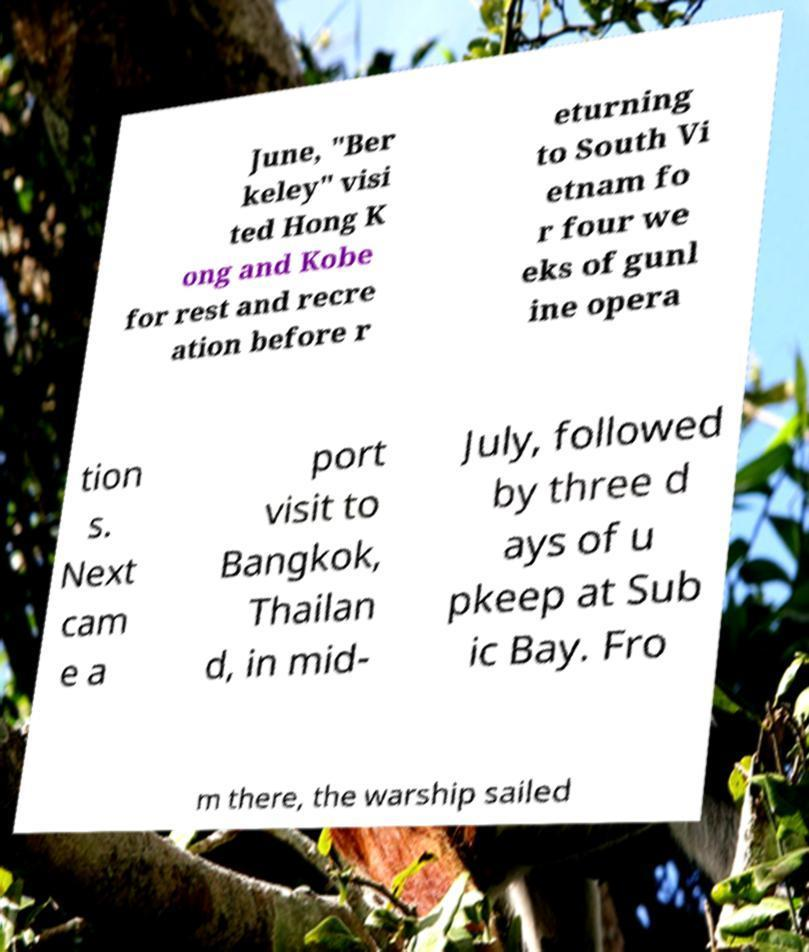For documentation purposes, I need the text within this image transcribed. Could you provide that? June, "Ber keley" visi ted Hong K ong and Kobe for rest and recre ation before r eturning to South Vi etnam fo r four we eks of gunl ine opera tion s. Next cam e a port visit to Bangkok, Thailan d, in mid- July, followed by three d ays of u pkeep at Sub ic Bay. Fro m there, the warship sailed 